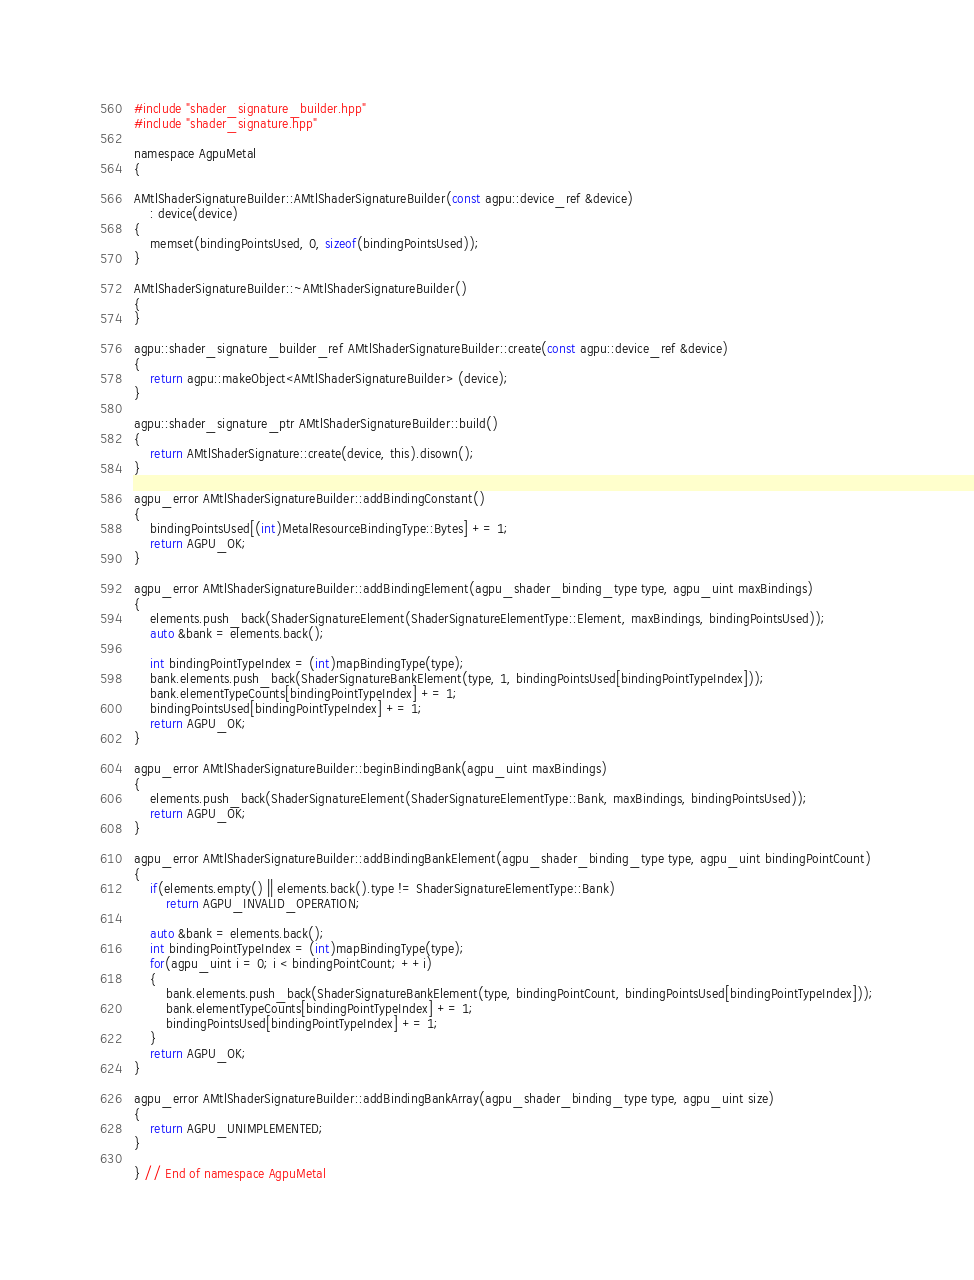Convert code to text. <code><loc_0><loc_0><loc_500><loc_500><_ObjectiveC_>#include "shader_signature_builder.hpp"
#include "shader_signature.hpp"

namespace AgpuMetal
{
    
AMtlShaderSignatureBuilder::AMtlShaderSignatureBuilder(const agpu::device_ref &device)
    : device(device)
{
    memset(bindingPointsUsed, 0, sizeof(bindingPointsUsed));
}

AMtlShaderSignatureBuilder::~AMtlShaderSignatureBuilder()
{
}

agpu::shader_signature_builder_ref AMtlShaderSignatureBuilder::create(const agpu::device_ref &device)
{
    return agpu::makeObject<AMtlShaderSignatureBuilder> (device);
}

agpu::shader_signature_ptr AMtlShaderSignatureBuilder::build()
{
    return AMtlShaderSignature::create(device, this).disown();
}

agpu_error AMtlShaderSignatureBuilder::addBindingConstant()
{
    bindingPointsUsed[(int)MetalResourceBindingType::Bytes] += 1;
    return AGPU_OK;
}

agpu_error AMtlShaderSignatureBuilder::addBindingElement(agpu_shader_binding_type type, agpu_uint maxBindings)
{
    elements.push_back(ShaderSignatureElement(ShaderSignatureElementType::Element, maxBindings, bindingPointsUsed));
    auto &bank = elements.back();

    int bindingPointTypeIndex = (int)mapBindingType(type);
    bank.elements.push_back(ShaderSignatureBankElement(type, 1, bindingPointsUsed[bindingPointTypeIndex]));
    bank.elementTypeCounts[bindingPointTypeIndex] += 1;
    bindingPointsUsed[bindingPointTypeIndex] += 1;
    return AGPU_OK;
}

agpu_error AMtlShaderSignatureBuilder::beginBindingBank(agpu_uint maxBindings)
{
    elements.push_back(ShaderSignatureElement(ShaderSignatureElementType::Bank, maxBindings, bindingPointsUsed));
    return AGPU_OK;
}

agpu_error AMtlShaderSignatureBuilder::addBindingBankElement(agpu_shader_binding_type type, agpu_uint bindingPointCount)
{
    if(elements.empty() || elements.back().type != ShaderSignatureElementType::Bank)
        return AGPU_INVALID_OPERATION;

    auto &bank = elements.back();
    int bindingPointTypeIndex = (int)mapBindingType(type);
    for(agpu_uint i = 0; i < bindingPointCount; ++i)
    {
        bank.elements.push_back(ShaderSignatureBankElement(type, bindingPointCount, bindingPointsUsed[bindingPointTypeIndex]));
        bank.elementTypeCounts[bindingPointTypeIndex] += 1;
        bindingPointsUsed[bindingPointTypeIndex] += 1;
    }
    return AGPU_OK;
}

agpu_error AMtlShaderSignatureBuilder::addBindingBankArray(agpu_shader_binding_type type, agpu_uint size)
{
    return AGPU_UNIMPLEMENTED;
}

} // End of namespace AgpuMetal
</code> 